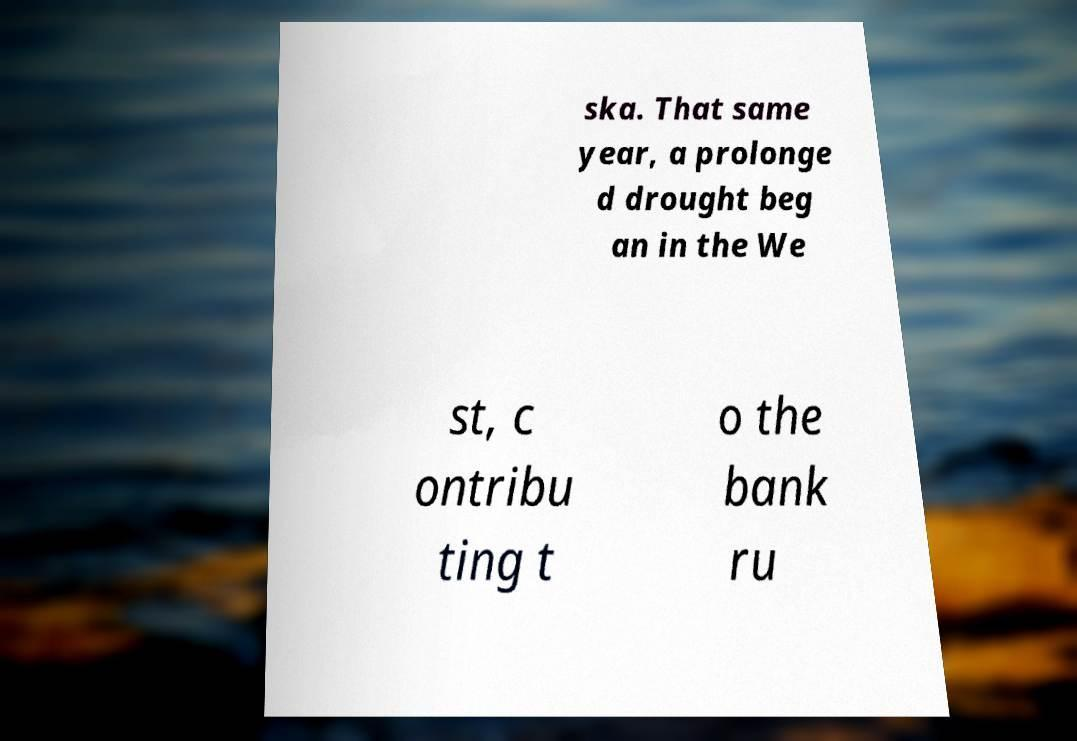I need the written content from this picture converted into text. Can you do that? ska. That same year, a prolonge d drought beg an in the We st, c ontribu ting t o the bank ru 